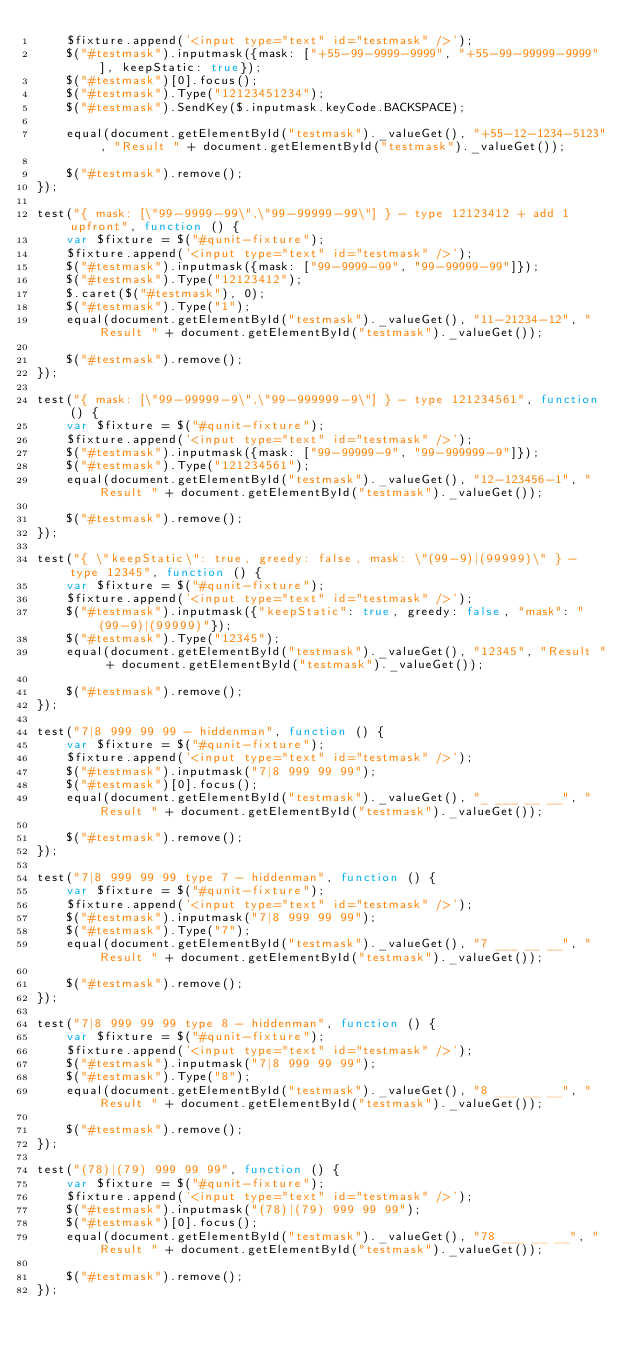Convert code to text. <code><loc_0><loc_0><loc_500><loc_500><_JavaScript_>    $fixture.append('<input type="text" id="testmask" />');
    $("#testmask").inputmask({mask: ["+55-99-9999-9999", "+55-99-99999-9999"], keepStatic: true});
    $("#testmask")[0].focus();
    $("#testmask").Type("12123451234");
    $("#testmask").SendKey($.inputmask.keyCode.BACKSPACE);

    equal(document.getElementById("testmask")._valueGet(), "+55-12-1234-5123", "Result " + document.getElementById("testmask")._valueGet());

    $("#testmask").remove();
});

test("{ mask: [\"99-9999-99\",\"99-99999-99\"] } - type 12123412 + add 1 upfront", function () {
    var $fixture = $("#qunit-fixture");
    $fixture.append('<input type="text" id="testmask" />');
    $("#testmask").inputmask({mask: ["99-9999-99", "99-99999-99"]});
    $("#testmask").Type("12123412");
    $.caret($("#testmask"), 0);
    $("#testmask").Type("1");
    equal(document.getElementById("testmask")._valueGet(), "11-21234-12", "Result " + document.getElementById("testmask")._valueGet());

    $("#testmask").remove();
});

test("{ mask: [\"99-99999-9\",\"99-999999-9\"] } - type 121234561", function () {
    var $fixture = $("#qunit-fixture");
    $fixture.append('<input type="text" id="testmask" />');
    $("#testmask").inputmask({mask: ["99-99999-9", "99-999999-9"]});
    $("#testmask").Type("121234561");
    equal(document.getElementById("testmask")._valueGet(), "12-123456-1", "Result " + document.getElementById("testmask")._valueGet());

    $("#testmask").remove();
});

test("{ \"keepStatic\": true, greedy: false, mask: \"(99-9)|(99999)\" } - type 12345", function () {
    var $fixture = $("#qunit-fixture");
    $fixture.append('<input type="text" id="testmask" />');
    $("#testmask").inputmask({"keepStatic": true, greedy: false, "mask": "(99-9)|(99999)"});
    $("#testmask").Type("12345");
    equal(document.getElementById("testmask")._valueGet(), "12345", "Result " + document.getElementById("testmask")._valueGet());

    $("#testmask").remove();
});

test("7|8 999 99 99 - hiddenman", function () {
    var $fixture = $("#qunit-fixture");
    $fixture.append('<input type="text" id="testmask" />');
    $("#testmask").inputmask("7|8 999 99 99");
    $("#testmask")[0].focus();
    equal(document.getElementById("testmask")._valueGet(), "_ ___ __ __", "Result " + document.getElementById("testmask")._valueGet());

    $("#testmask").remove();
});

test("7|8 999 99 99 type 7 - hiddenman", function () {
    var $fixture = $("#qunit-fixture");
    $fixture.append('<input type="text" id="testmask" />');
    $("#testmask").inputmask("7|8 999 99 99");
    $("#testmask").Type("7");
    equal(document.getElementById("testmask")._valueGet(), "7 ___ __ __", "Result " + document.getElementById("testmask")._valueGet());

    $("#testmask").remove();
});

test("7|8 999 99 99 type 8 - hiddenman", function () {
    var $fixture = $("#qunit-fixture");
    $fixture.append('<input type="text" id="testmask" />');
    $("#testmask").inputmask("7|8 999 99 99");
    $("#testmask").Type("8");
    equal(document.getElementById("testmask")._valueGet(), "8 ___ __ __", "Result " + document.getElementById("testmask")._valueGet());

    $("#testmask").remove();
});

test("(78)|(79) 999 99 99", function () {
    var $fixture = $("#qunit-fixture");
    $fixture.append('<input type="text" id="testmask" />');
    $("#testmask").inputmask("(78)|(79) 999 99 99");
    $("#testmask")[0].focus();
    equal(document.getElementById("testmask")._valueGet(), "78 ___ __ __", "Result " + document.getElementById("testmask")._valueGet());

    $("#testmask").remove();
});
</code> 